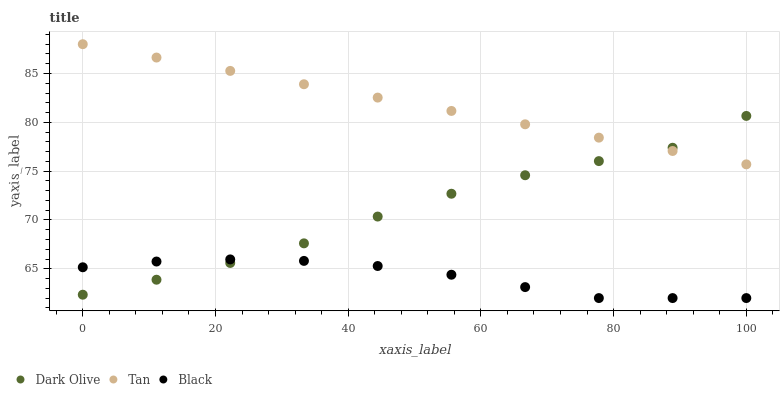Does Black have the minimum area under the curve?
Answer yes or no. Yes. Does Tan have the maximum area under the curve?
Answer yes or no. Yes. Does Dark Olive have the minimum area under the curve?
Answer yes or no. No. Does Dark Olive have the maximum area under the curve?
Answer yes or no. No. Is Tan the smoothest?
Answer yes or no. Yes. Is Dark Olive the roughest?
Answer yes or no. Yes. Is Black the smoothest?
Answer yes or no. No. Is Black the roughest?
Answer yes or no. No. Does Black have the lowest value?
Answer yes or no. Yes. Does Dark Olive have the lowest value?
Answer yes or no. No. Does Tan have the highest value?
Answer yes or no. Yes. Does Dark Olive have the highest value?
Answer yes or no. No. Is Black less than Tan?
Answer yes or no. Yes. Is Tan greater than Black?
Answer yes or no. Yes. Does Dark Olive intersect Tan?
Answer yes or no. Yes. Is Dark Olive less than Tan?
Answer yes or no. No. Is Dark Olive greater than Tan?
Answer yes or no. No. Does Black intersect Tan?
Answer yes or no. No. 